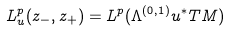<formula> <loc_0><loc_0><loc_500><loc_500>L _ { u } ^ { p } ( z _ { - } , z _ { + } ) = L ^ { p } ( \Lambda ^ { ( 0 , 1 ) } u ^ { \ast } T M )</formula> 